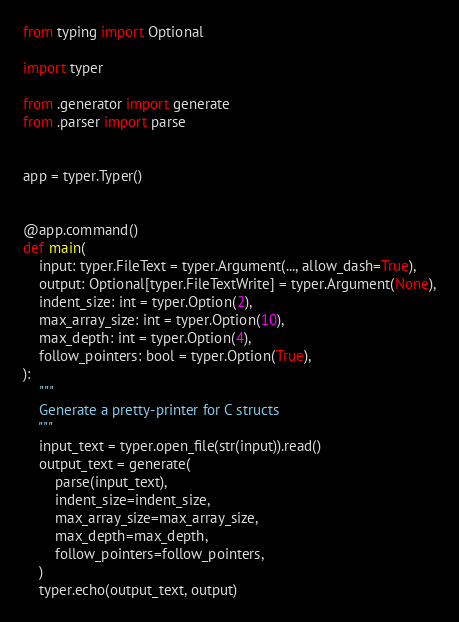Convert code to text. <code><loc_0><loc_0><loc_500><loc_500><_Python_>from typing import Optional

import typer

from .generator import generate
from .parser import parse


app = typer.Typer()


@app.command()
def main(
    input: typer.FileText = typer.Argument(..., allow_dash=True),
    output: Optional[typer.FileTextWrite] = typer.Argument(None),
    indent_size: int = typer.Option(2),
    max_array_size: int = typer.Option(10),
    max_depth: int = typer.Option(4),
    follow_pointers: bool = typer.Option(True),
):
    """
    Generate a pretty-printer for C structs
    """
    input_text = typer.open_file(str(input)).read()
    output_text = generate(
        parse(input_text),
        indent_size=indent_size,
        max_array_size=max_array_size,
        max_depth=max_depth,
        follow_pointers=follow_pointers,
    )
    typer.echo(output_text, output)
</code> 